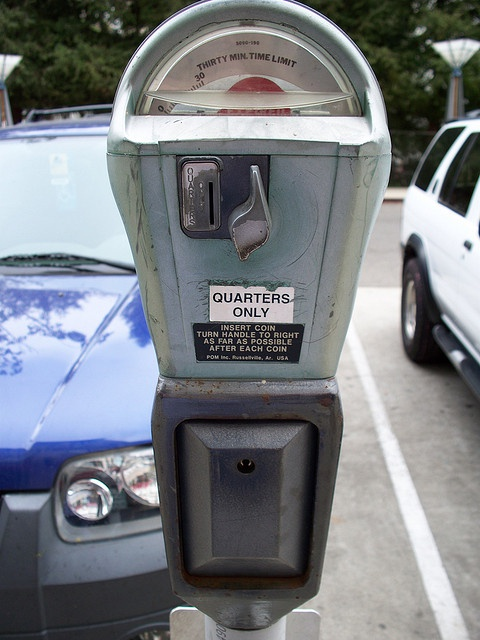Describe the objects in this image and their specific colors. I can see parking meter in black, gray, darkgray, and lightgray tones, car in black, lavender, darkgray, and gray tones, and car in black, white, gray, and darkgray tones in this image. 